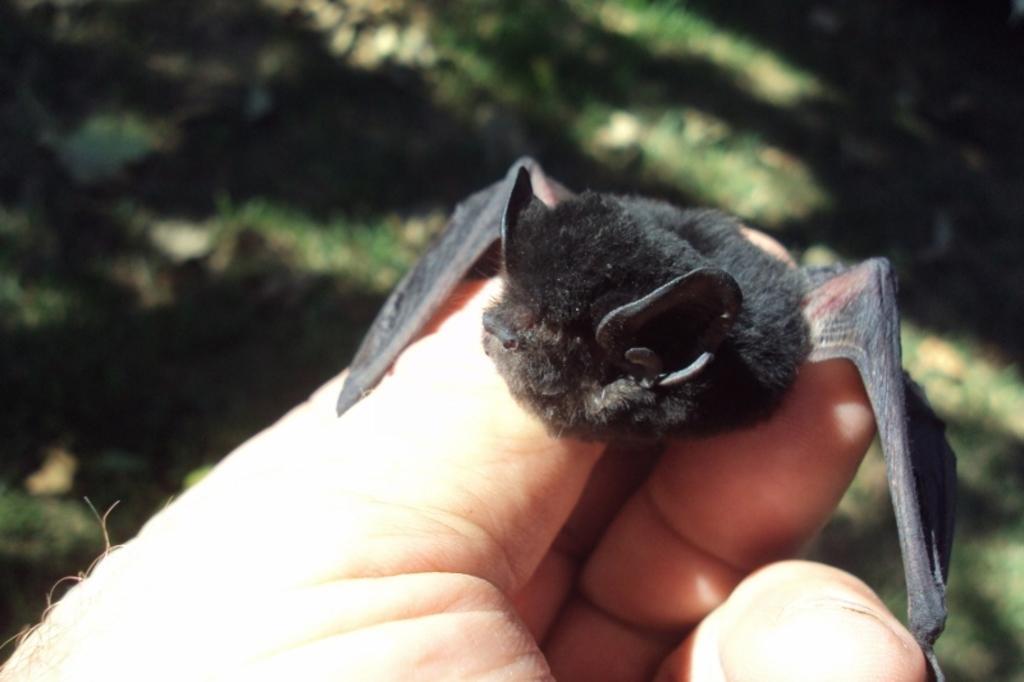In one or two sentences, can you explain what this image depicts? In this image, we can see a hand holding a bat. In the background, image is blurred. 